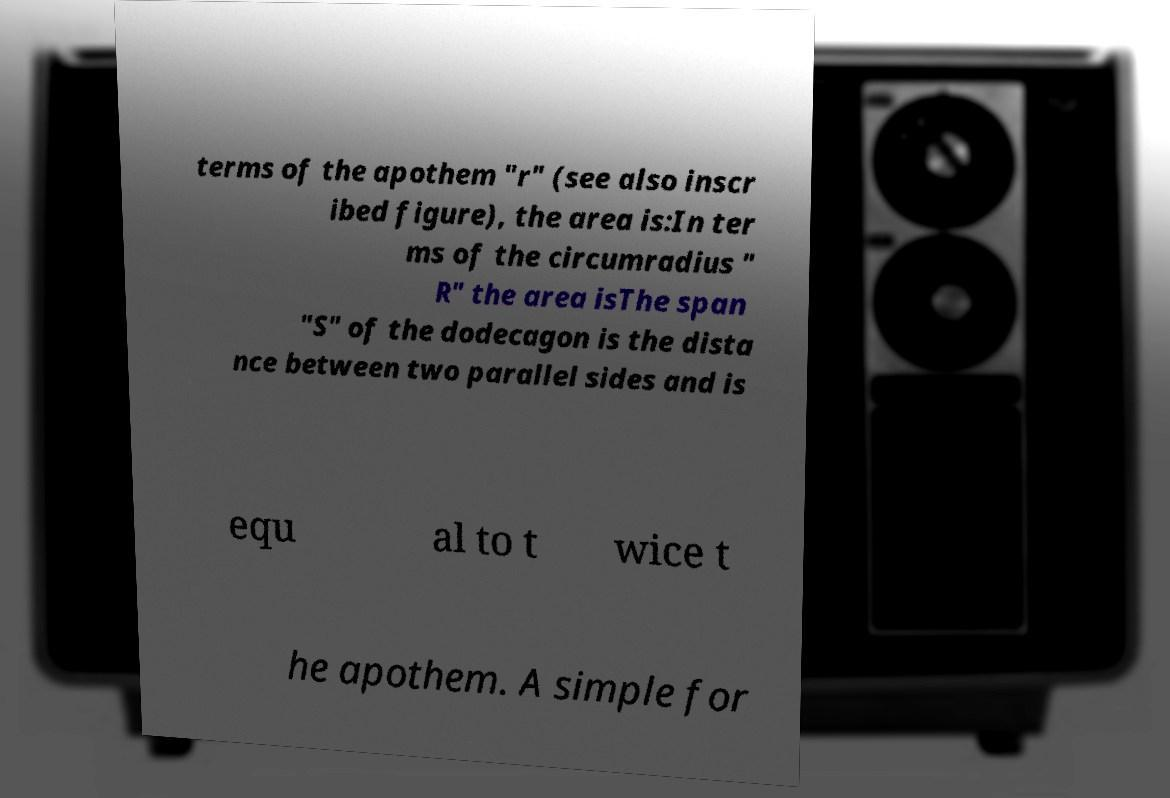What messages or text are displayed in this image? I need them in a readable, typed format. terms of the apothem "r" (see also inscr ibed figure), the area is:In ter ms of the circumradius " R" the area isThe span "S" of the dodecagon is the dista nce between two parallel sides and is equ al to t wice t he apothem. A simple for 